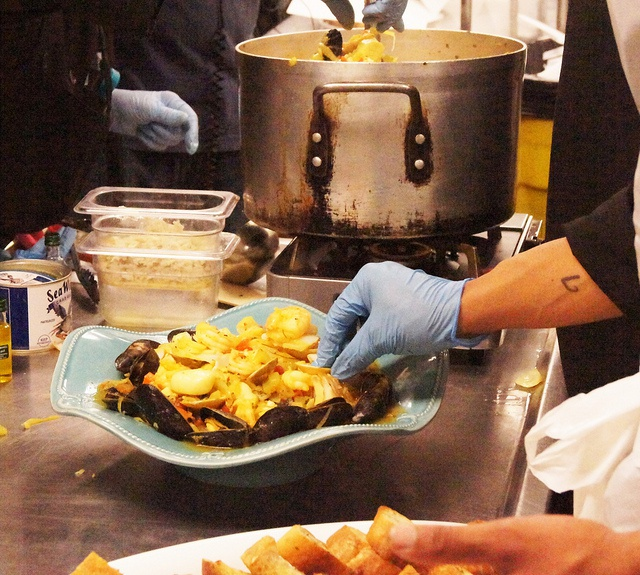Describe the objects in this image and their specific colors. I can see oven in black, brown, and maroon tones, people in black, orange, darkgray, and lightgray tones, bowl in black, beige, gold, and maroon tones, people in black, gray, darkgray, and lightgray tones, and people in black and brown tones in this image. 